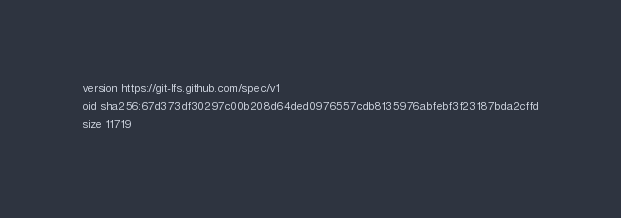<code> <loc_0><loc_0><loc_500><loc_500><_HTML_>version https://git-lfs.github.com/spec/v1
oid sha256:67d373df30297c00b208d64ded0976557cdb8135976abfebf3f23187bda2cffd
size 11719
</code> 